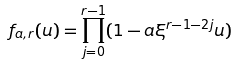<formula> <loc_0><loc_0><loc_500><loc_500>f _ { a , r } ( u ) = \prod _ { j = 0 } ^ { r - 1 } ( 1 - a \xi ^ { r - 1 - 2 j } u )</formula> 